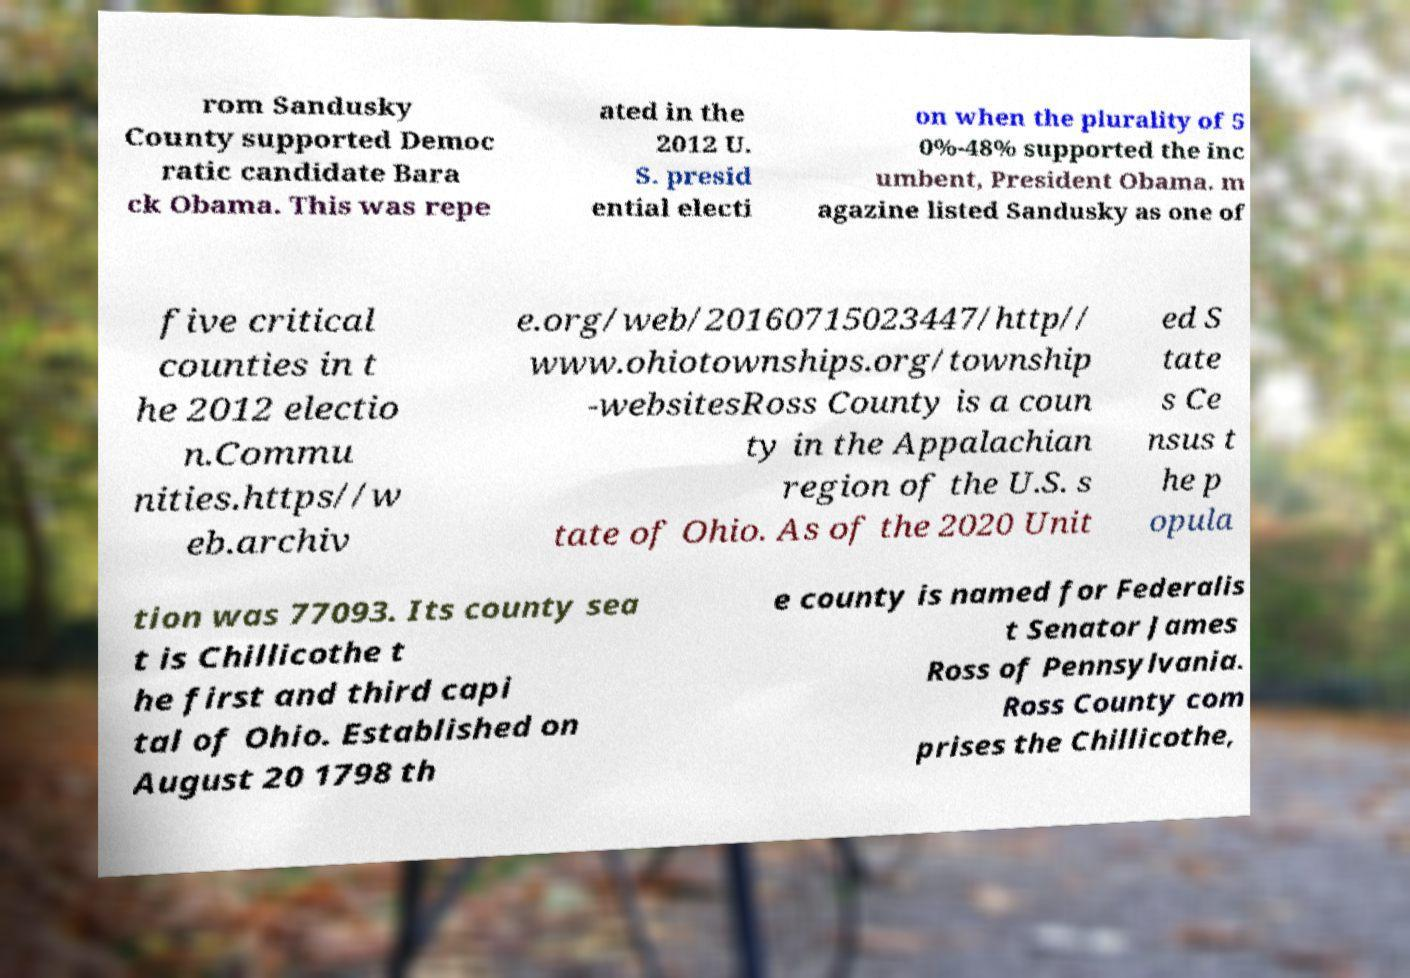Can you read and provide the text displayed in the image?This photo seems to have some interesting text. Can you extract and type it out for me? rom Sandusky County supported Democ ratic candidate Bara ck Obama. This was repe ated in the 2012 U. S. presid ential electi on when the plurality of 5 0%-48% supported the inc umbent, President Obama. m agazine listed Sandusky as one of five critical counties in t he 2012 electio n.Commu nities.https//w eb.archiv e.org/web/20160715023447/http// www.ohiotownships.org/township -websitesRoss County is a coun ty in the Appalachian region of the U.S. s tate of Ohio. As of the 2020 Unit ed S tate s Ce nsus t he p opula tion was 77093. Its county sea t is Chillicothe t he first and third capi tal of Ohio. Established on August 20 1798 th e county is named for Federalis t Senator James Ross of Pennsylvania. Ross County com prises the Chillicothe, 